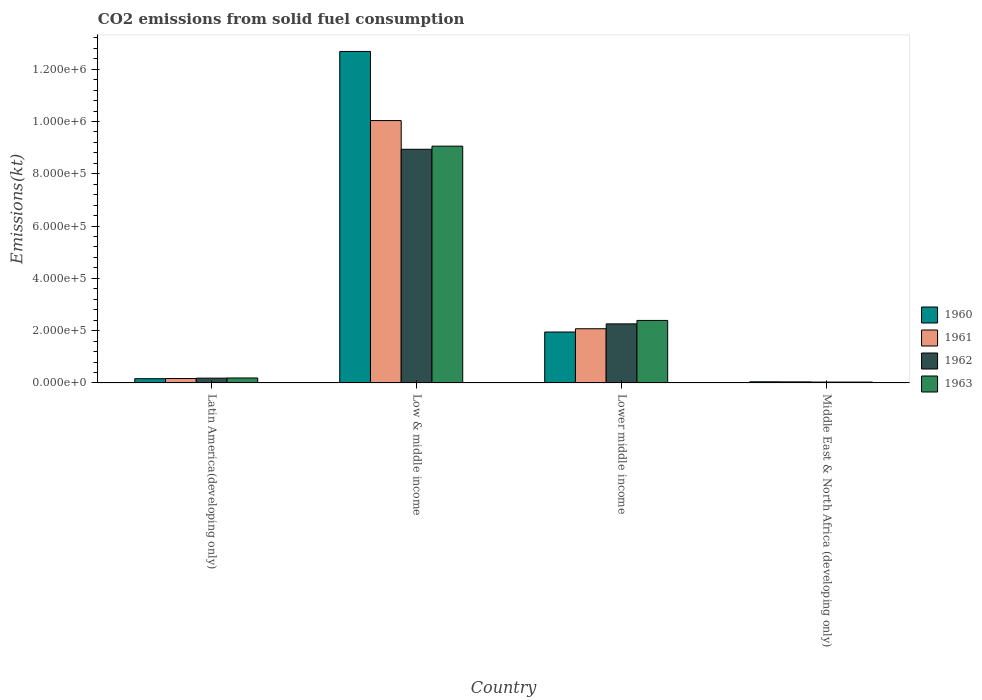Are the number of bars per tick equal to the number of legend labels?
Offer a very short reply. Yes. Are the number of bars on each tick of the X-axis equal?
Keep it short and to the point. Yes. How many bars are there on the 1st tick from the right?
Ensure brevity in your answer.  4. What is the label of the 2nd group of bars from the left?
Offer a terse response. Low & middle income. What is the amount of CO2 emitted in 1960 in Middle East & North Africa (developing only)?
Offer a very short reply. 4356.8. Across all countries, what is the maximum amount of CO2 emitted in 1960?
Ensure brevity in your answer.  1.27e+06. Across all countries, what is the minimum amount of CO2 emitted in 1962?
Provide a short and direct response. 3311.16. In which country was the amount of CO2 emitted in 1960 maximum?
Your answer should be compact. Low & middle income. In which country was the amount of CO2 emitted in 1961 minimum?
Make the answer very short. Middle East & North Africa (developing only). What is the total amount of CO2 emitted in 1962 in the graph?
Offer a very short reply. 1.14e+06. What is the difference between the amount of CO2 emitted in 1960 in Low & middle income and that in Middle East & North Africa (developing only)?
Your answer should be very brief. 1.26e+06. What is the difference between the amount of CO2 emitted in 1961 in Low & middle income and the amount of CO2 emitted in 1963 in Lower middle income?
Your answer should be compact. 7.64e+05. What is the average amount of CO2 emitted in 1960 per country?
Your answer should be compact. 3.71e+05. What is the difference between the amount of CO2 emitted of/in 1962 and amount of CO2 emitted of/in 1961 in Middle East & North Africa (developing only)?
Give a very brief answer. -791.29. What is the ratio of the amount of CO2 emitted in 1963 in Lower middle income to that in Middle East & North Africa (developing only)?
Offer a terse response. 72.42. Is the difference between the amount of CO2 emitted in 1962 in Latin America(developing only) and Lower middle income greater than the difference between the amount of CO2 emitted in 1961 in Latin America(developing only) and Lower middle income?
Offer a very short reply. No. What is the difference between the highest and the second highest amount of CO2 emitted in 1961?
Give a very brief answer. 1.90e+05. What is the difference between the highest and the lowest amount of CO2 emitted in 1962?
Give a very brief answer. 8.90e+05. In how many countries, is the amount of CO2 emitted in 1963 greater than the average amount of CO2 emitted in 1963 taken over all countries?
Give a very brief answer. 1. What does the 3rd bar from the right in Lower middle income represents?
Provide a succinct answer. 1961. Is it the case that in every country, the sum of the amount of CO2 emitted in 1961 and amount of CO2 emitted in 1963 is greater than the amount of CO2 emitted in 1962?
Offer a terse response. Yes. How many bars are there?
Give a very brief answer. 16. How many countries are there in the graph?
Provide a short and direct response. 4. What is the difference between two consecutive major ticks on the Y-axis?
Offer a very short reply. 2.00e+05. Does the graph contain grids?
Your answer should be very brief. No. How many legend labels are there?
Give a very brief answer. 4. How are the legend labels stacked?
Offer a very short reply. Vertical. What is the title of the graph?
Offer a very short reply. CO2 emissions from solid fuel consumption. What is the label or title of the Y-axis?
Offer a very short reply. Emissions(kt). What is the Emissions(kt) in 1960 in Latin America(developing only)?
Ensure brevity in your answer.  1.62e+04. What is the Emissions(kt) of 1961 in Latin America(developing only)?
Ensure brevity in your answer.  1.70e+04. What is the Emissions(kt) in 1962 in Latin America(developing only)?
Your answer should be compact. 1.83e+04. What is the Emissions(kt) of 1963 in Latin America(developing only)?
Your response must be concise. 1.90e+04. What is the Emissions(kt) of 1960 in Low & middle income?
Offer a terse response. 1.27e+06. What is the Emissions(kt) of 1961 in Low & middle income?
Offer a very short reply. 1.00e+06. What is the Emissions(kt) in 1962 in Low & middle income?
Your answer should be very brief. 8.94e+05. What is the Emissions(kt) in 1963 in Low & middle income?
Your answer should be very brief. 9.06e+05. What is the Emissions(kt) of 1960 in Lower middle income?
Provide a succinct answer. 1.95e+05. What is the Emissions(kt) of 1961 in Lower middle income?
Make the answer very short. 2.07e+05. What is the Emissions(kt) in 1962 in Lower middle income?
Offer a terse response. 2.26e+05. What is the Emissions(kt) of 1963 in Lower middle income?
Your answer should be compact. 2.39e+05. What is the Emissions(kt) of 1960 in Middle East & North Africa (developing only)?
Your answer should be compact. 4356.8. What is the Emissions(kt) of 1961 in Middle East & North Africa (developing only)?
Your answer should be very brief. 4102.45. What is the Emissions(kt) in 1962 in Middle East & North Africa (developing only)?
Your answer should be very brief. 3311.16. What is the Emissions(kt) in 1963 in Middle East & North Africa (developing only)?
Your response must be concise. 3301.74. Across all countries, what is the maximum Emissions(kt) of 1960?
Offer a very short reply. 1.27e+06. Across all countries, what is the maximum Emissions(kt) in 1961?
Offer a terse response. 1.00e+06. Across all countries, what is the maximum Emissions(kt) of 1962?
Provide a succinct answer. 8.94e+05. Across all countries, what is the maximum Emissions(kt) in 1963?
Provide a succinct answer. 9.06e+05. Across all countries, what is the minimum Emissions(kt) in 1960?
Offer a terse response. 4356.8. Across all countries, what is the minimum Emissions(kt) in 1961?
Offer a very short reply. 4102.45. Across all countries, what is the minimum Emissions(kt) of 1962?
Give a very brief answer. 3311.16. Across all countries, what is the minimum Emissions(kt) of 1963?
Give a very brief answer. 3301.74. What is the total Emissions(kt) of 1960 in the graph?
Ensure brevity in your answer.  1.48e+06. What is the total Emissions(kt) in 1961 in the graph?
Offer a very short reply. 1.23e+06. What is the total Emissions(kt) of 1962 in the graph?
Your response must be concise. 1.14e+06. What is the total Emissions(kt) of 1963 in the graph?
Provide a succinct answer. 1.17e+06. What is the difference between the Emissions(kt) in 1960 in Latin America(developing only) and that in Low & middle income?
Give a very brief answer. -1.25e+06. What is the difference between the Emissions(kt) in 1961 in Latin America(developing only) and that in Low & middle income?
Offer a very short reply. -9.86e+05. What is the difference between the Emissions(kt) of 1962 in Latin America(developing only) and that in Low & middle income?
Provide a succinct answer. -8.75e+05. What is the difference between the Emissions(kt) of 1963 in Latin America(developing only) and that in Low & middle income?
Your response must be concise. -8.87e+05. What is the difference between the Emissions(kt) of 1960 in Latin America(developing only) and that in Lower middle income?
Your answer should be compact. -1.79e+05. What is the difference between the Emissions(kt) of 1961 in Latin America(developing only) and that in Lower middle income?
Your response must be concise. -1.90e+05. What is the difference between the Emissions(kt) in 1962 in Latin America(developing only) and that in Lower middle income?
Offer a terse response. -2.08e+05. What is the difference between the Emissions(kt) of 1963 in Latin America(developing only) and that in Lower middle income?
Your answer should be very brief. -2.20e+05. What is the difference between the Emissions(kt) of 1960 in Latin America(developing only) and that in Middle East & North Africa (developing only)?
Make the answer very short. 1.19e+04. What is the difference between the Emissions(kt) in 1961 in Latin America(developing only) and that in Middle East & North Africa (developing only)?
Offer a terse response. 1.29e+04. What is the difference between the Emissions(kt) of 1962 in Latin America(developing only) and that in Middle East & North Africa (developing only)?
Offer a terse response. 1.50e+04. What is the difference between the Emissions(kt) in 1963 in Latin America(developing only) and that in Middle East & North Africa (developing only)?
Offer a terse response. 1.57e+04. What is the difference between the Emissions(kt) of 1960 in Low & middle income and that in Lower middle income?
Provide a short and direct response. 1.07e+06. What is the difference between the Emissions(kt) of 1961 in Low & middle income and that in Lower middle income?
Provide a short and direct response. 7.96e+05. What is the difference between the Emissions(kt) of 1962 in Low & middle income and that in Lower middle income?
Ensure brevity in your answer.  6.68e+05. What is the difference between the Emissions(kt) in 1963 in Low & middle income and that in Lower middle income?
Give a very brief answer. 6.67e+05. What is the difference between the Emissions(kt) of 1960 in Low & middle income and that in Middle East & North Africa (developing only)?
Give a very brief answer. 1.26e+06. What is the difference between the Emissions(kt) of 1961 in Low & middle income and that in Middle East & North Africa (developing only)?
Your answer should be compact. 9.99e+05. What is the difference between the Emissions(kt) of 1962 in Low & middle income and that in Middle East & North Africa (developing only)?
Offer a very short reply. 8.90e+05. What is the difference between the Emissions(kt) in 1963 in Low & middle income and that in Middle East & North Africa (developing only)?
Provide a succinct answer. 9.02e+05. What is the difference between the Emissions(kt) in 1960 in Lower middle income and that in Middle East & North Africa (developing only)?
Your answer should be compact. 1.90e+05. What is the difference between the Emissions(kt) in 1961 in Lower middle income and that in Middle East & North Africa (developing only)?
Offer a terse response. 2.03e+05. What is the difference between the Emissions(kt) of 1962 in Lower middle income and that in Middle East & North Africa (developing only)?
Ensure brevity in your answer.  2.23e+05. What is the difference between the Emissions(kt) in 1963 in Lower middle income and that in Middle East & North Africa (developing only)?
Your answer should be very brief. 2.36e+05. What is the difference between the Emissions(kt) of 1960 in Latin America(developing only) and the Emissions(kt) of 1961 in Low & middle income?
Give a very brief answer. -9.87e+05. What is the difference between the Emissions(kt) of 1960 in Latin America(developing only) and the Emissions(kt) of 1962 in Low & middle income?
Provide a succinct answer. -8.77e+05. What is the difference between the Emissions(kt) of 1960 in Latin America(developing only) and the Emissions(kt) of 1963 in Low & middle income?
Your response must be concise. -8.89e+05. What is the difference between the Emissions(kt) in 1961 in Latin America(developing only) and the Emissions(kt) in 1962 in Low & middle income?
Provide a succinct answer. -8.77e+05. What is the difference between the Emissions(kt) of 1961 in Latin America(developing only) and the Emissions(kt) of 1963 in Low & middle income?
Offer a terse response. -8.89e+05. What is the difference between the Emissions(kt) of 1962 in Latin America(developing only) and the Emissions(kt) of 1963 in Low & middle income?
Your answer should be very brief. -8.87e+05. What is the difference between the Emissions(kt) in 1960 in Latin America(developing only) and the Emissions(kt) in 1961 in Lower middle income?
Offer a very short reply. -1.91e+05. What is the difference between the Emissions(kt) in 1960 in Latin America(developing only) and the Emissions(kt) in 1962 in Lower middle income?
Provide a short and direct response. -2.10e+05. What is the difference between the Emissions(kt) of 1960 in Latin America(developing only) and the Emissions(kt) of 1963 in Lower middle income?
Offer a terse response. -2.23e+05. What is the difference between the Emissions(kt) in 1961 in Latin America(developing only) and the Emissions(kt) in 1962 in Lower middle income?
Provide a succinct answer. -2.09e+05. What is the difference between the Emissions(kt) in 1961 in Latin America(developing only) and the Emissions(kt) in 1963 in Lower middle income?
Ensure brevity in your answer.  -2.22e+05. What is the difference between the Emissions(kt) in 1962 in Latin America(developing only) and the Emissions(kt) in 1963 in Lower middle income?
Provide a short and direct response. -2.21e+05. What is the difference between the Emissions(kt) in 1960 in Latin America(developing only) and the Emissions(kt) in 1961 in Middle East & North Africa (developing only)?
Provide a short and direct response. 1.21e+04. What is the difference between the Emissions(kt) in 1960 in Latin America(developing only) and the Emissions(kt) in 1962 in Middle East & North Africa (developing only)?
Your answer should be very brief. 1.29e+04. What is the difference between the Emissions(kt) of 1960 in Latin America(developing only) and the Emissions(kt) of 1963 in Middle East & North Africa (developing only)?
Give a very brief answer. 1.29e+04. What is the difference between the Emissions(kt) of 1961 in Latin America(developing only) and the Emissions(kt) of 1962 in Middle East & North Africa (developing only)?
Keep it short and to the point. 1.37e+04. What is the difference between the Emissions(kt) in 1961 in Latin America(developing only) and the Emissions(kt) in 1963 in Middle East & North Africa (developing only)?
Give a very brief answer. 1.37e+04. What is the difference between the Emissions(kt) in 1962 in Latin America(developing only) and the Emissions(kt) in 1963 in Middle East & North Africa (developing only)?
Ensure brevity in your answer.  1.50e+04. What is the difference between the Emissions(kt) in 1960 in Low & middle income and the Emissions(kt) in 1961 in Lower middle income?
Your answer should be compact. 1.06e+06. What is the difference between the Emissions(kt) of 1960 in Low & middle income and the Emissions(kt) of 1962 in Lower middle income?
Provide a short and direct response. 1.04e+06. What is the difference between the Emissions(kt) of 1960 in Low & middle income and the Emissions(kt) of 1963 in Lower middle income?
Offer a very short reply. 1.03e+06. What is the difference between the Emissions(kt) in 1961 in Low & middle income and the Emissions(kt) in 1962 in Lower middle income?
Your response must be concise. 7.78e+05. What is the difference between the Emissions(kt) of 1961 in Low & middle income and the Emissions(kt) of 1963 in Lower middle income?
Ensure brevity in your answer.  7.64e+05. What is the difference between the Emissions(kt) in 1962 in Low & middle income and the Emissions(kt) in 1963 in Lower middle income?
Offer a terse response. 6.55e+05. What is the difference between the Emissions(kt) in 1960 in Low & middle income and the Emissions(kt) in 1961 in Middle East & North Africa (developing only)?
Offer a terse response. 1.26e+06. What is the difference between the Emissions(kt) in 1960 in Low & middle income and the Emissions(kt) in 1962 in Middle East & North Africa (developing only)?
Provide a succinct answer. 1.26e+06. What is the difference between the Emissions(kt) in 1960 in Low & middle income and the Emissions(kt) in 1963 in Middle East & North Africa (developing only)?
Your answer should be compact. 1.26e+06. What is the difference between the Emissions(kt) in 1961 in Low & middle income and the Emissions(kt) in 1962 in Middle East & North Africa (developing only)?
Make the answer very short. 1.00e+06. What is the difference between the Emissions(kt) of 1961 in Low & middle income and the Emissions(kt) of 1963 in Middle East & North Africa (developing only)?
Offer a terse response. 1.00e+06. What is the difference between the Emissions(kt) in 1962 in Low & middle income and the Emissions(kt) in 1963 in Middle East & North Africa (developing only)?
Provide a succinct answer. 8.90e+05. What is the difference between the Emissions(kt) in 1960 in Lower middle income and the Emissions(kt) in 1961 in Middle East & North Africa (developing only)?
Your response must be concise. 1.91e+05. What is the difference between the Emissions(kt) of 1960 in Lower middle income and the Emissions(kt) of 1962 in Middle East & North Africa (developing only)?
Give a very brief answer. 1.91e+05. What is the difference between the Emissions(kt) in 1960 in Lower middle income and the Emissions(kt) in 1963 in Middle East & North Africa (developing only)?
Your response must be concise. 1.92e+05. What is the difference between the Emissions(kt) in 1961 in Lower middle income and the Emissions(kt) in 1962 in Middle East & North Africa (developing only)?
Give a very brief answer. 2.04e+05. What is the difference between the Emissions(kt) in 1961 in Lower middle income and the Emissions(kt) in 1963 in Middle East & North Africa (developing only)?
Keep it short and to the point. 2.04e+05. What is the difference between the Emissions(kt) in 1962 in Lower middle income and the Emissions(kt) in 1963 in Middle East & North Africa (developing only)?
Make the answer very short. 2.23e+05. What is the average Emissions(kt) in 1960 per country?
Keep it short and to the point. 3.71e+05. What is the average Emissions(kt) in 1961 per country?
Offer a very short reply. 3.08e+05. What is the average Emissions(kt) of 1962 per country?
Offer a very short reply. 2.85e+05. What is the average Emissions(kt) in 1963 per country?
Give a very brief answer. 2.92e+05. What is the difference between the Emissions(kt) in 1960 and Emissions(kt) in 1961 in Latin America(developing only)?
Your answer should be very brief. -728.34. What is the difference between the Emissions(kt) of 1960 and Emissions(kt) of 1962 in Latin America(developing only)?
Provide a succinct answer. -2101.12. What is the difference between the Emissions(kt) in 1960 and Emissions(kt) in 1963 in Latin America(developing only)?
Keep it short and to the point. -2718.88. What is the difference between the Emissions(kt) of 1961 and Emissions(kt) of 1962 in Latin America(developing only)?
Give a very brief answer. -1372.79. What is the difference between the Emissions(kt) of 1961 and Emissions(kt) of 1963 in Latin America(developing only)?
Your answer should be compact. -1990.54. What is the difference between the Emissions(kt) in 1962 and Emissions(kt) in 1963 in Latin America(developing only)?
Your answer should be compact. -617.75. What is the difference between the Emissions(kt) of 1960 and Emissions(kt) of 1961 in Low & middle income?
Keep it short and to the point. 2.64e+05. What is the difference between the Emissions(kt) of 1960 and Emissions(kt) of 1962 in Low & middle income?
Your response must be concise. 3.74e+05. What is the difference between the Emissions(kt) in 1960 and Emissions(kt) in 1963 in Low & middle income?
Your answer should be compact. 3.62e+05. What is the difference between the Emissions(kt) of 1961 and Emissions(kt) of 1962 in Low & middle income?
Your answer should be very brief. 1.10e+05. What is the difference between the Emissions(kt) in 1961 and Emissions(kt) in 1963 in Low & middle income?
Keep it short and to the point. 9.78e+04. What is the difference between the Emissions(kt) in 1962 and Emissions(kt) in 1963 in Low & middle income?
Ensure brevity in your answer.  -1.20e+04. What is the difference between the Emissions(kt) of 1960 and Emissions(kt) of 1961 in Lower middle income?
Offer a very short reply. -1.25e+04. What is the difference between the Emissions(kt) of 1960 and Emissions(kt) of 1962 in Lower middle income?
Make the answer very short. -3.10e+04. What is the difference between the Emissions(kt) of 1960 and Emissions(kt) of 1963 in Lower middle income?
Your answer should be very brief. -4.43e+04. What is the difference between the Emissions(kt) of 1961 and Emissions(kt) of 1962 in Lower middle income?
Your answer should be compact. -1.86e+04. What is the difference between the Emissions(kt) of 1961 and Emissions(kt) of 1963 in Lower middle income?
Offer a very short reply. -3.18e+04. What is the difference between the Emissions(kt) of 1962 and Emissions(kt) of 1963 in Lower middle income?
Make the answer very short. -1.32e+04. What is the difference between the Emissions(kt) of 1960 and Emissions(kt) of 1961 in Middle East & North Africa (developing only)?
Your answer should be compact. 254.34. What is the difference between the Emissions(kt) of 1960 and Emissions(kt) of 1962 in Middle East & North Africa (developing only)?
Your response must be concise. 1045.63. What is the difference between the Emissions(kt) in 1960 and Emissions(kt) in 1963 in Middle East & North Africa (developing only)?
Your response must be concise. 1055.05. What is the difference between the Emissions(kt) of 1961 and Emissions(kt) of 1962 in Middle East & North Africa (developing only)?
Ensure brevity in your answer.  791.29. What is the difference between the Emissions(kt) in 1961 and Emissions(kt) in 1963 in Middle East & North Africa (developing only)?
Your response must be concise. 800.71. What is the difference between the Emissions(kt) of 1962 and Emissions(kt) of 1963 in Middle East & North Africa (developing only)?
Give a very brief answer. 9.42. What is the ratio of the Emissions(kt) in 1960 in Latin America(developing only) to that in Low & middle income?
Give a very brief answer. 0.01. What is the ratio of the Emissions(kt) of 1961 in Latin America(developing only) to that in Low & middle income?
Your response must be concise. 0.02. What is the ratio of the Emissions(kt) of 1962 in Latin America(developing only) to that in Low & middle income?
Your answer should be compact. 0.02. What is the ratio of the Emissions(kt) in 1963 in Latin America(developing only) to that in Low & middle income?
Your response must be concise. 0.02. What is the ratio of the Emissions(kt) of 1960 in Latin America(developing only) to that in Lower middle income?
Keep it short and to the point. 0.08. What is the ratio of the Emissions(kt) of 1961 in Latin America(developing only) to that in Lower middle income?
Your answer should be compact. 0.08. What is the ratio of the Emissions(kt) in 1962 in Latin America(developing only) to that in Lower middle income?
Give a very brief answer. 0.08. What is the ratio of the Emissions(kt) in 1963 in Latin America(developing only) to that in Lower middle income?
Offer a terse response. 0.08. What is the ratio of the Emissions(kt) in 1960 in Latin America(developing only) to that in Middle East & North Africa (developing only)?
Your answer should be compact. 3.73. What is the ratio of the Emissions(kt) in 1961 in Latin America(developing only) to that in Middle East & North Africa (developing only)?
Your response must be concise. 4.14. What is the ratio of the Emissions(kt) in 1962 in Latin America(developing only) to that in Middle East & North Africa (developing only)?
Offer a terse response. 5.54. What is the ratio of the Emissions(kt) of 1963 in Latin America(developing only) to that in Middle East & North Africa (developing only)?
Give a very brief answer. 5.74. What is the ratio of the Emissions(kt) of 1960 in Low & middle income to that in Lower middle income?
Give a very brief answer. 6.51. What is the ratio of the Emissions(kt) of 1961 in Low & middle income to that in Lower middle income?
Your answer should be very brief. 4.84. What is the ratio of the Emissions(kt) in 1962 in Low & middle income to that in Lower middle income?
Give a very brief answer. 3.96. What is the ratio of the Emissions(kt) of 1963 in Low & middle income to that in Lower middle income?
Offer a terse response. 3.79. What is the ratio of the Emissions(kt) in 1960 in Low & middle income to that in Middle East & North Africa (developing only)?
Provide a short and direct response. 291. What is the ratio of the Emissions(kt) in 1961 in Low & middle income to that in Middle East & North Africa (developing only)?
Make the answer very short. 244.6. What is the ratio of the Emissions(kt) in 1962 in Low & middle income to that in Middle East & North Africa (developing only)?
Your answer should be compact. 269.9. What is the ratio of the Emissions(kt) of 1963 in Low & middle income to that in Middle East & North Africa (developing only)?
Give a very brief answer. 274.29. What is the ratio of the Emissions(kt) of 1960 in Lower middle income to that in Middle East & North Africa (developing only)?
Give a very brief answer. 44.71. What is the ratio of the Emissions(kt) of 1961 in Lower middle income to that in Middle East & North Africa (developing only)?
Make the answer very short. 50.53. What is the ratio of the Emissions(kt) of 1962 in Lower middle income to that in Middle East & North Africa (developing only)?
Make the answer very short. 68.21. What is the ratio of the Emissions(kt) of 1963 in Lower middle income to that in Middle East & North Africa (developing only)?
Your response must be concise. 72.42. What is the difference between the highest and the second highest Emissions(kt) of 1960?
Ensure brevity in your answer.  1.07e+06. What is the difference between the highest and the second highest Emissions(kt) in 1961?
Offer a very short reply. 7.96e+05. What is the difference between the highest and the second highest Emissions(kt) in 1962?
Ensure brevity in your answer.  6.68e+05. What is the difference between the highest and the second highest Emissions(kt) of 1963?
Make the answer very short. 6.67e+05. What is the difference between the highest and the lowest Emissions(kt) in 1960?
Your answer should be very brief. 1.26e+06. What is the difference between the highest and the lowest Emissions(kt) of 1961?
Ensure brevity in your answer.  9.99e+05. What is the difference between the highest and the lowest Emissions(kt) of 1962?
Ensure brevity in your answer.  8.90e+05. What is the difference between the highest and the lowest Emissions(kt) of 1963?
Offer a terse response. 9.02e+05. 